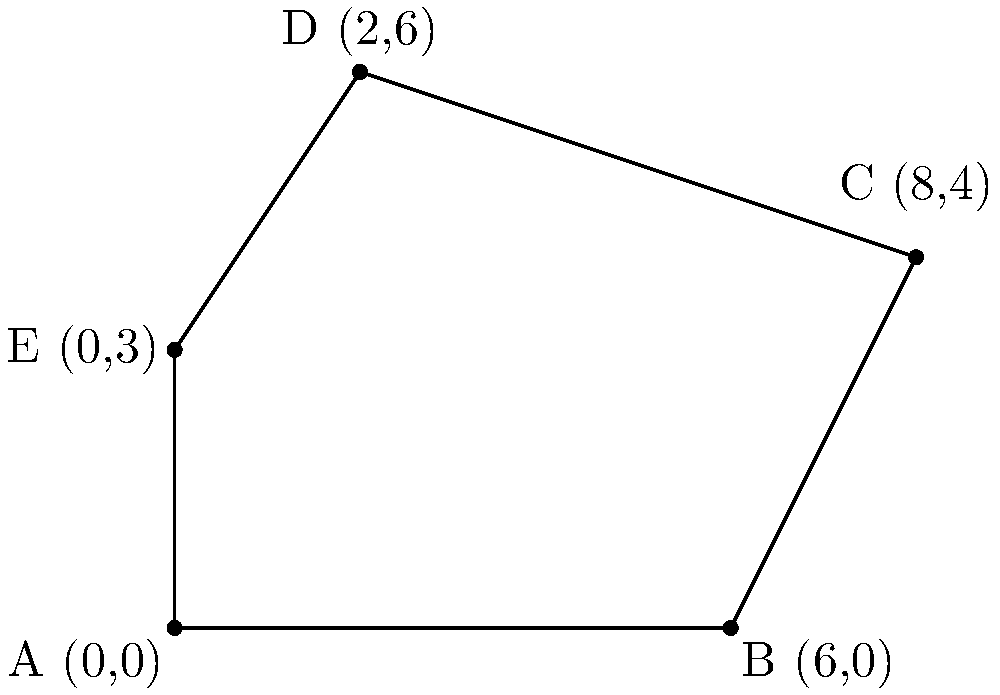As a candidate concerned about fair voting practices, you're tasked with determining the area of an irregularly shaped voting district. The district is represented by the polygon ABCDE in the coordinate plane above. Calculate the area of this voting district using coordinate geometry methods. To calculate the area of the irregular polygon ABCDE, we can use the Shoelace formula (also known as the surveyor's formula). The steps are as follows:

1) List the coordinates of the vertices in order:
   A(0,0), B(6,0), C(8,4), D(2,6), E(0,3)

2) Apply the Shoelace formula:
   Area = $\frac{1}{2}|((x_1y_2 + x_2y_3 + ... + x_ny_1) - (y_1x_2 + y_2x_3 + ... + y_nx_1))|$

3) Substitute the values:
   Area = $\frac{1}{2}|((0 \cdot 0 + 6 \cdot 4 + 8 \cdot 6 + 2 \cdot 3 + 0 \cdot 0) - (0 \cdot 6 + 0 \cdot 8 + 4 \cdot 2 + 6 \cdot 0 + 3 \cdot 0))|$

4) Calculate:
   Area = $\frac{1}{2}|((0 + 24 + 48 + 6 + 0) - (0 + 0 + 8 + 0 + 0))|$
   Area = $\frac{1}{2}|(78 - 8)|$
   Area = $\frac{1}{2}(70)$
   Area = 35

Therefore, the area of the voting district is 35 square units.
Answer: 35 square units 